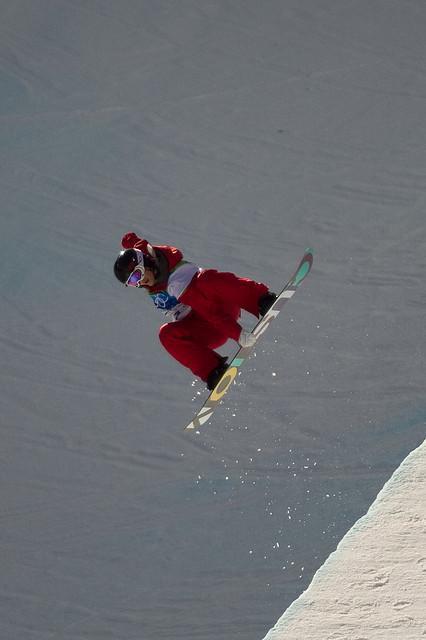How many bus riders are leaning out of a bus window?
Give a very brief answer. 0. 